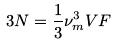Convert formula to latex. <formula><loc_0><loc_0><loc_500><loc_500>3 N = \frac { 1 } { 3 } \nu _ { m } ^ { 3 } V F</formula> 